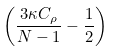<formula> <loc_0><loc_0><loc_500><loc_500>\left ( \frac { 3 \kappa C _ { \rho } } { N - 1 } - \frac { 1 } { 2 } \right )</formula> 